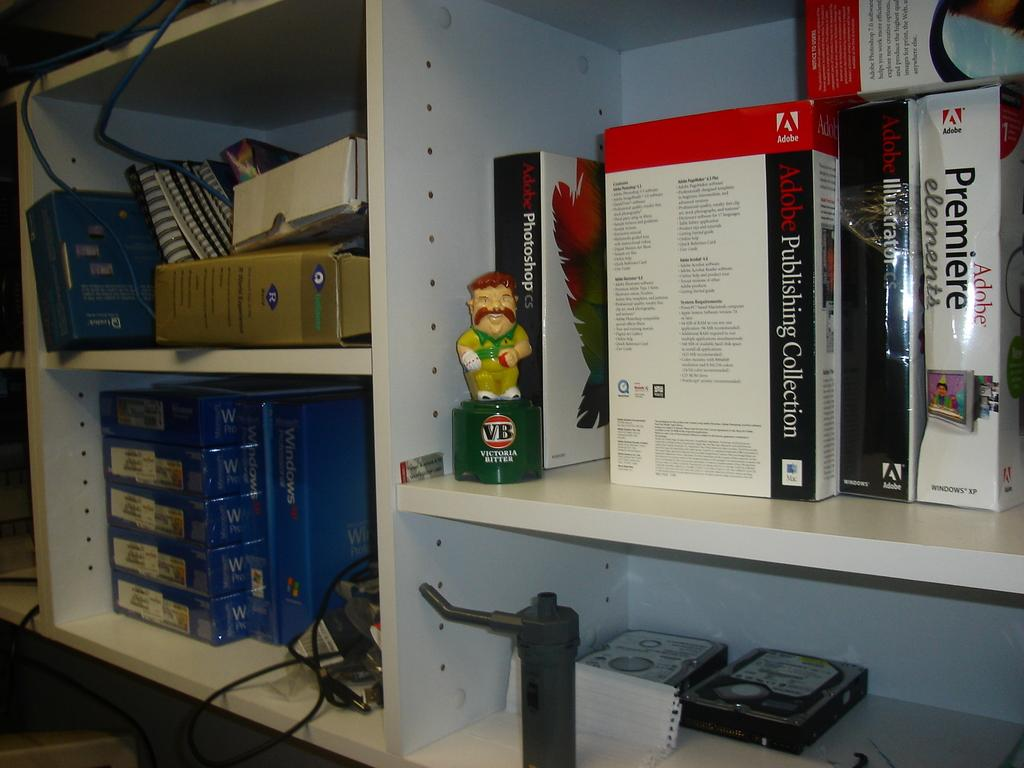Provide a one-sentence caption for the provided image. a few shelves, one has a Adobe Premiere elements book and VB decanter on it. 